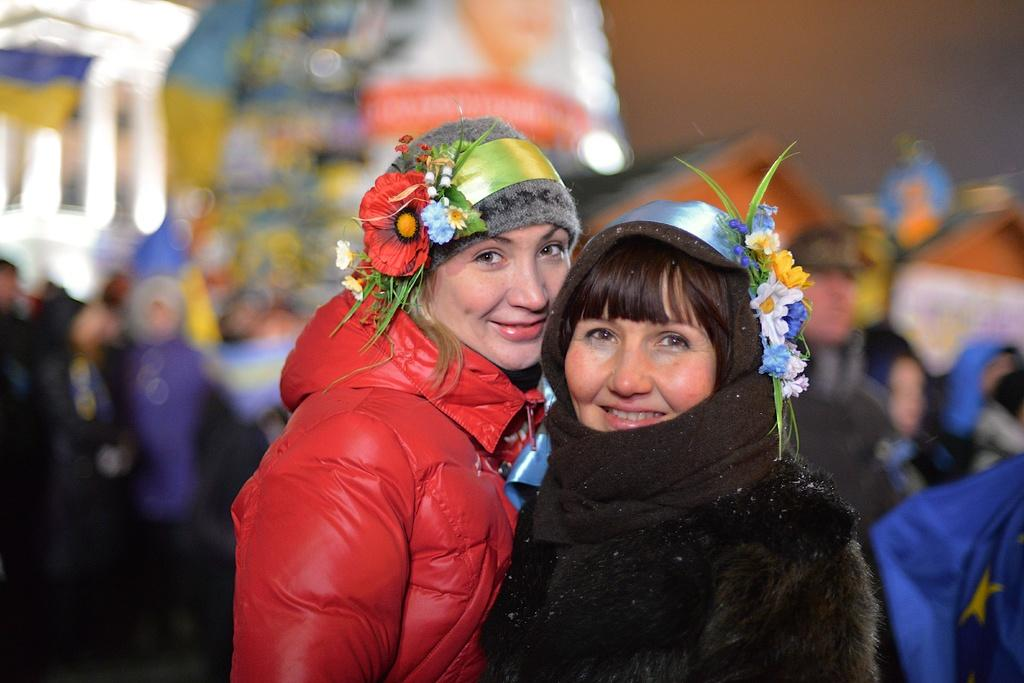How many women are in the image? There are two women in the image. What colors are the dresses worn by the women? One woman is wearing a red dress, and the other is wearing a black dress. What can be seen on the heads of the women? There are flowers on the heads of the women. What else can be seen in the background of the image? There are other people and objects in the background of the image. What type of oil can be seen dripping from the corn in the image? There is no corn or oil present in the image; it features two women with flowers on their heads. 